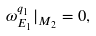Convert formula to latex. <formula><loc_0><loc_0><loc_500><loc_500>\omega ^ { q _ { 1 } } _ { E _ { 1 } } | _ { M _ { 2 } } = 0 ,</formula> 